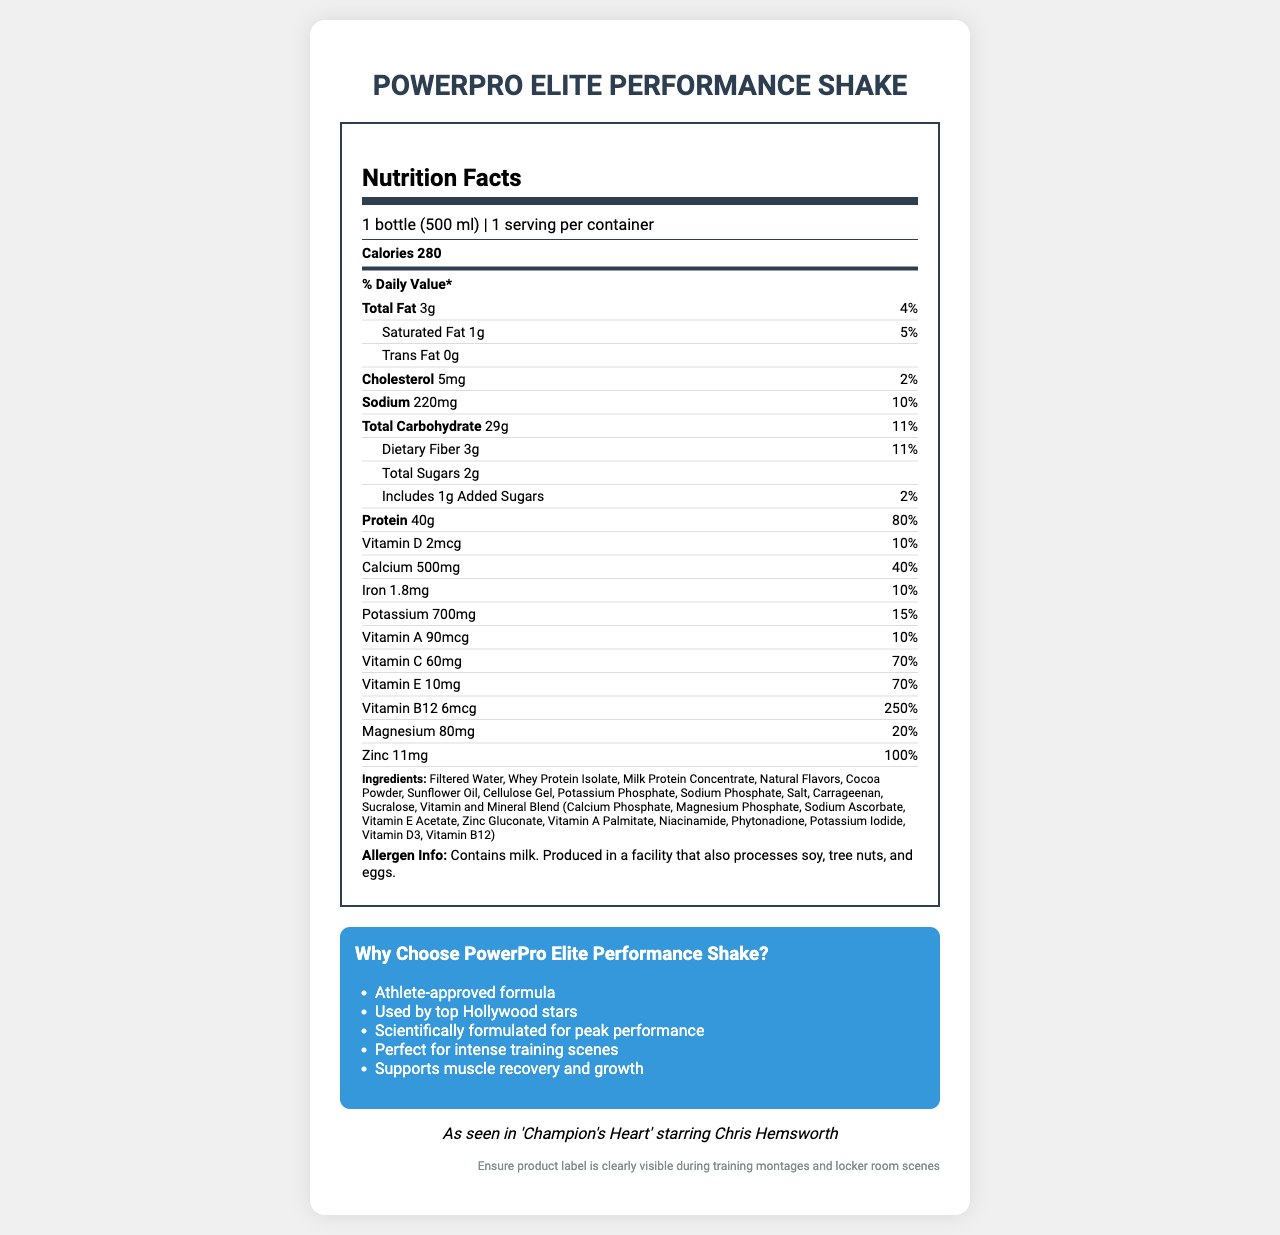what is the serving size for PowerPro Elite Performance Shake? The serving size is stated as "1 bottle (500 ml)" in the serving information section.
Answer: 1 bottle (500 ml) how many calories are in one serving? The calorie count is clearly listed as "Calories 280".
Answer: 280 what is the amount of protein per serving? The protein amount is listed in the nutrient section under "Protein".
Answer: 40g how much total fat does it contain? The total fat amount is listed as "Total Fat 3g".
Answer: 3g what is the daily value percentage of saturated fat? The daily value percentage of saturated fat is given as "5%" in the saturated fat section.
Answer: 5% which vitamins are included and their daily values? A. Vitamin A - 10%, Vitamin C - 70%, Vitamin D - 10% B. Vitamin A - 15%, Vitamin C - 65%, Vitamin D - 20% C. Vitamin A - 10%, Vitamin C - 50%, Vitamin D - 5% D. Vitamin A - 5%, Vitamin C - 70%, Vitamin D - 10% The document lists Vitamin A with 10%, Vitamin C with 70%, and Vitamin D with 10% daily values.
Answer: A what are the first three ingredients listed in the ingredients section? A. Whey Protein Isolate, Milk Protein Concentrate, Cocoa Powder B. Filtered Water, Whey Protein Isolate, Milk Protein Concentrate C. Filtered Water, Cocoa Powder, Sunflower Oil D. Whey Protein Isolate, Natural Flavors, Milk Protein Concentrate The first three ingredients are Filtered Water, Whey Protein Isolate, and Milk Protein Concentrate.
Answer: B does the product contain any allergens? The allergen information section states, "Contains milk. Produced in a facility that also processes soy, tree nuts, and eggs."
Answer: Yes what are the marketing claims made for this product? The marketing claims are listed under the marketing section and include: Athlete-approved formula, Used by top Hollywood stars, Scientifically formulated for peak performance, Perfect for intense training scenes, Supports muscle recovery and growth.
Answer: Athlete-approved formula, Used by top Hollywood stars, Scientifically formulated for peak performance, Perfect for intense training scenes, Supports muscle recovery and growth summarize the main idea of the document. The document provides comprehensive information about the nutritional content, ingredients, potential allergens, and marketing highlights of the "PowerPro Elite Performance Shake", positioning it as a premium product associated with top-tier athletes and celebrities.
Answer: The document is a Nutrition Facts label for "PowerPro Elite Performance Shake", showing detailed nutritional information, ingredients, allergen information, and marketing claims, along with a fictional endorsement mentioning its appearance in the film "Champion’s Heart" starring Chris Hemsworth. who is the fictional endorsement attributed to? The fictional endorsement section mentions "As seen in 'Champion's Heart' starring Chris Hemsworth".
Answer: Chris Hemsworth what is the recommended daily value percentage for protein in this product? The daily value percentage for protein is listed as "80%" in the nutrient section.
Answer: 80% how much sodium is in one bottle? The sodium content is listed as "Sodium 220mg".
Answer: 220mg what is the daily value percentage of magnesium? Magnesium has a daily value percentage of 20%, as listed in the nutrient section.
Answer: 20% how should the product be placed for optimal exposure in films according to the document? The product placement note recommends the label should be visible during training montages and locker room scenes.
Answer: Ensure product label is clearly visible during training montages and locker room scenes how much total carbohydrate does one serving contain? The total carbohydrate amount is listed as "Total Carbohydrate 29g".
Answer: 29g how many added sugars are included in the total sugar amount? In the total sugars section, it mentions "Includes 1g Added Sugars".
Answer: 1g can we determine the price of the product from the document? The document does not provide any price information about the product.
Answer: Not enough information 